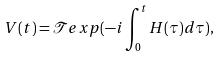Convert formula to latex. <formula><loc_0><loc_0><loc_500><loc_500>V ( t ) = \mathcal { T } e x p ( - i \int _ { 0 } ^ { t } H ( \tau ) d \tau ) ,</formula> 